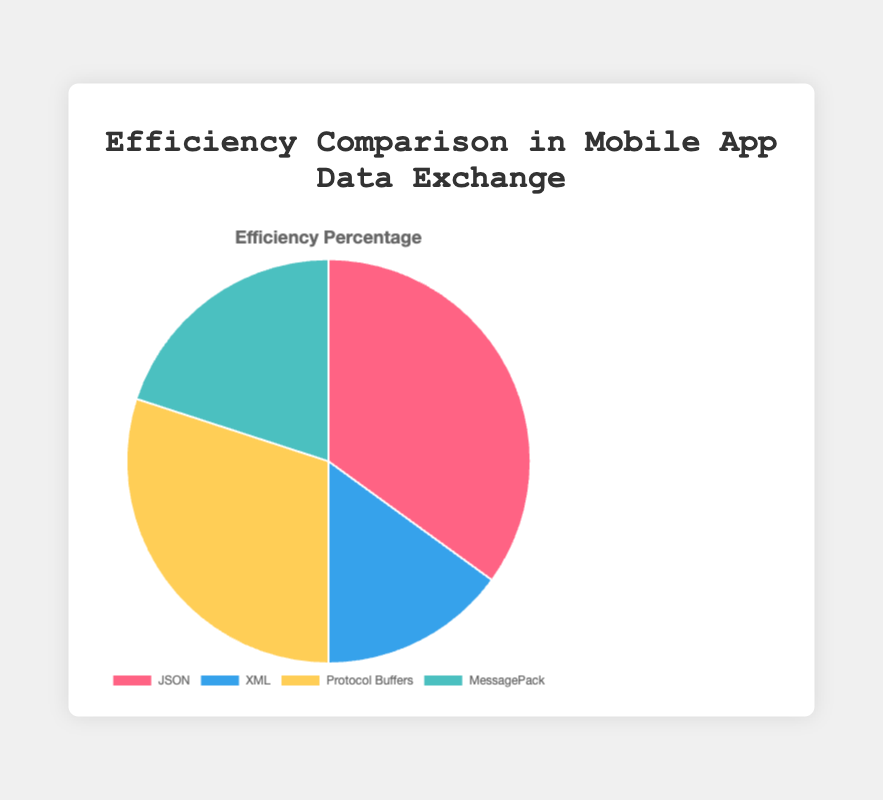Which entity has the highest efficiency percentage? The entity with the highest efficiency percentage is the one with the largest segment in the pie chart. JSON has the largest segment with an efficiency percentage of 35%.
Answer: JSON What is the combined efficiency percentage of Protocol Buffers and MessagePack? To find the combined efficiency percentage, add the efficiency percentages of both Protocol Buffers and MessagePack. Protocol Buffers has 30% and MessagePack has 20%. The sum is 30% + 20% = 50%.
Answer: 50% How much more efficient is JSON compared to XML? Subtract the efficiency percentage of XML from the efficiency percentage of JSON. JSON has 35% and XML has 15%. The difference is 35% - 15% = 20%.
Answer: 20% What is the difference in efficiency percentage between the most and least efficient entities? The most efficient entity is JSON with 35%, and the least efficient is XML with 15%. Subtract the smallest efficiency from the largest: 35% - 15% = 20%.
Answer: 20% Which entity is represented by the yellow segment in the pie chart? The yellow segment corresponds to Protocol Buffers, as indicated in the legend and unique color mappings.
Answer: Protocol Buffers Which two entities combined have the same efficiency percentage as JSON? Add the efficiency percentages of all combinations to find the one that equals JSON's 35%. Combining XML (15%) and MessagePack (20%) results in 15% + 20% = 35%.
Answer: XML and MessagePack Rank the entities from the most efficient to the least efficient. Sorting the entities by their efficiency percentages: JSON (35%), Protocol Buffers (30%), MessagePack (20%), and XML (15%).
Answer: JSON, Protocol Buffers, MessagePack, XML What percentage of the total efficiency is contributed by the two least efficient entities? Add the efficiency percentages of the two least efficient entities, XML (15%) and MessagePack (20%): 15% + 20% = 35%.
Answer: 35% Which entity is represented by the green segment in the pie chart? The green segment corresponds to MessagePack, as indicated by the legend and color mappings.
Answer: MessagePack What is the average efficiency percentage of all entities? Sum the efficiency percentages of all entities (35% + 15% + 30% + 20%) and divide by the number of entities (4): (35 + 15 + 30 + 20) / 4 = 100 / 4 = 25%.
Answer: 25% 